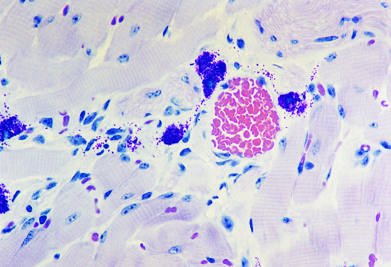what is the immediate reaction characterized by?
Answer the question using a single word or phrase. Vasodilation 